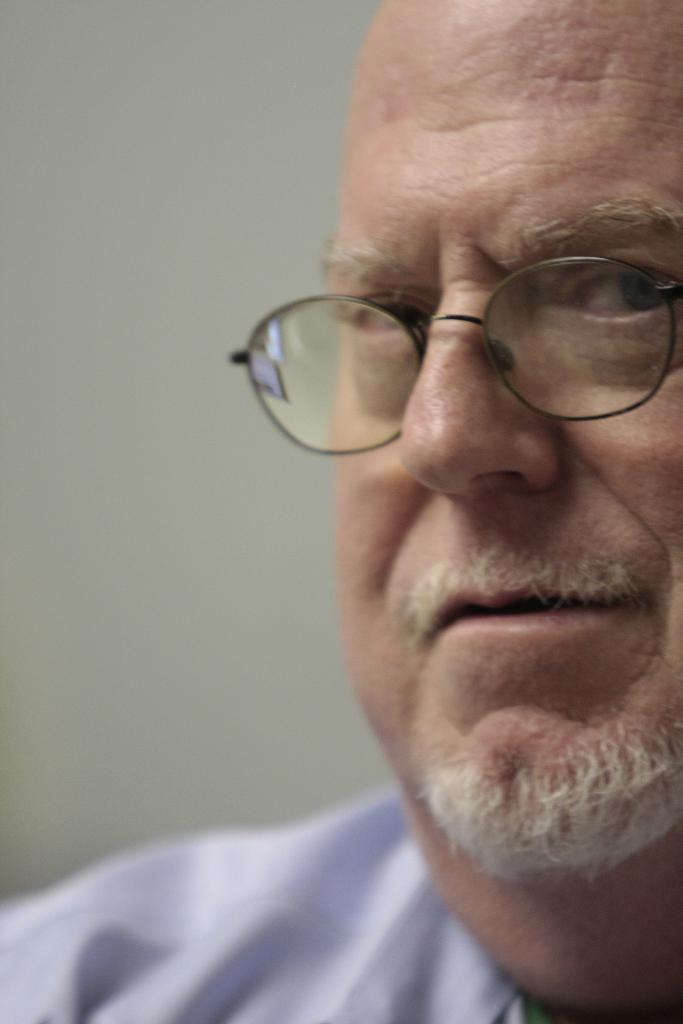What is the main subject in the foreground of the image? There is a person in the foreground of the image. What can be seen in the background of the image? There is a wall in the background of the image. Is the person in the image using a current to power a device? There is no indication in the image that the person is using a current to power a device, as the facts provided do not mention any electrical devices or power sources. 